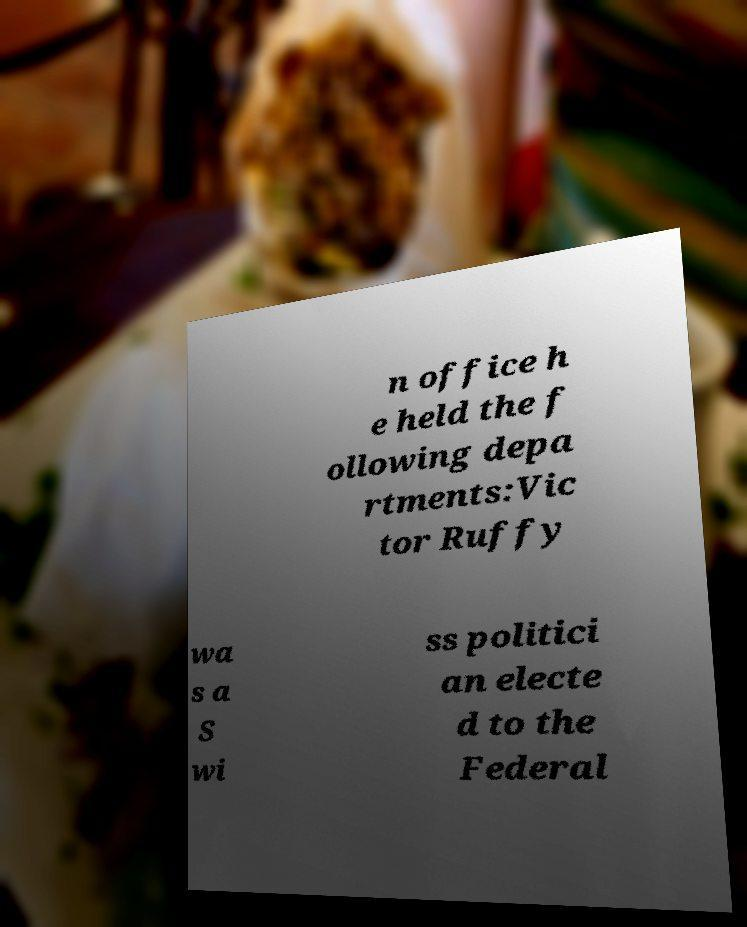There's text embedded in this image that I need extracted. Can you transcribe it verbatim? n office h e held the f ollowing depa rtments:Vic tor Ruffy wa s a S wi ss politici an electe d to the Federal 